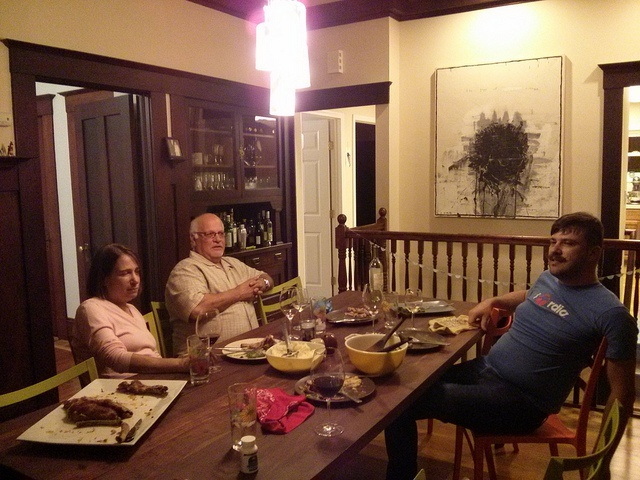Describe the objects in this image and their specific colors. I can see dining table in olive, maroon, black, brown, and tan tones, people in olive, black, maroon, and gray tones, people in olive, maroon, brown, tan, and black tones, people in olive, black, maroon, tan, and brown tones, and chair in olive, black, and maroon tones in this image. 